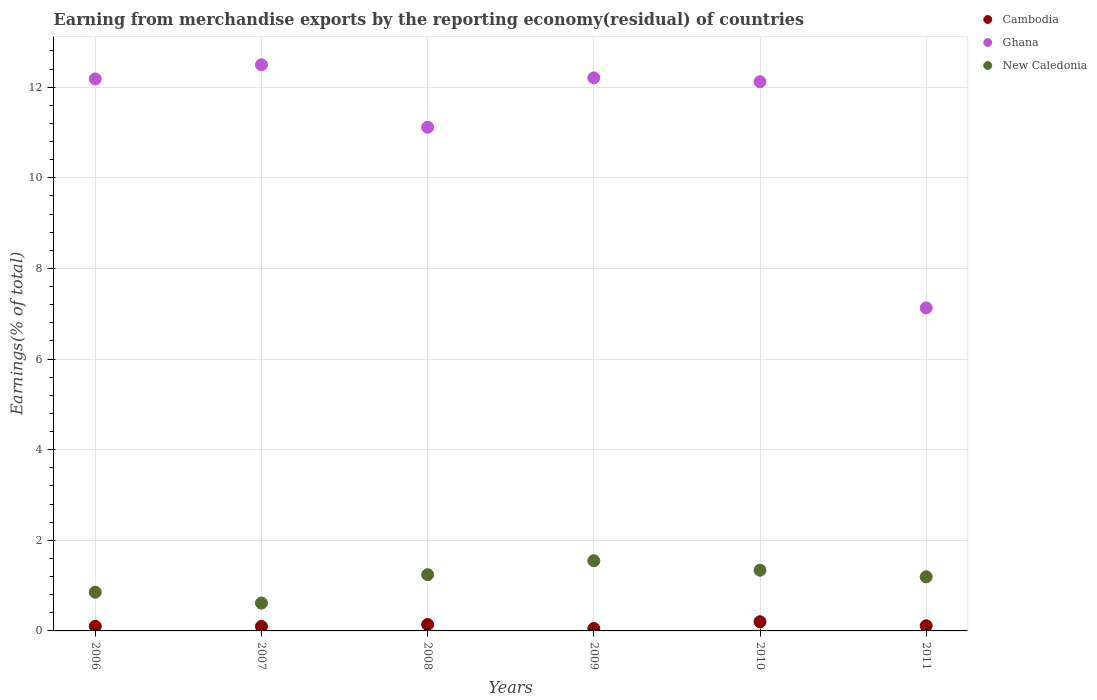How many different coloured dotlines are there?
Provide a succinct answer. 3. Is the number of dotlines equal to the number of legend labels?
Offer a terse response. Yes. What is the percentage of amount earned from merchandise exports in Cambodia in 2007?
Offer a very short reply. 0.1. Across all years, what is the maximum percentage of amount earned from merchandise exports in Ghana?
Provide a short and direct response. 12.5. Across all years, what is the minimum percentage of amount earned from merchandise exports in Cambodia?
Your answer should be compact. 0.05. What is the total percentage of amount earned from merchandise exports in New Caledonia in the graph?
Your answer should be very brief. 6.79. What is the difference between the percentage of amount earned from merchandise exports in New Caledonia in 2008 and that in 2011?
Your answer should be very brief. 0.05. What is the difference between the percentage of amount earned from merchandise exports in New Caledonia in 2011 and the percentage of amount earned from merchandise exports in Ghana in 2008?
Keep it short and to the point. -9.92. What is the average percentage of amount earned from merchandise exports in Ghana per year?
Give a very brief answer. 11.21. In the year 2009, what is the difference between the percentage of amount earned from merchandise exports in Cambodia and percentage of amount earned from merchandise exports in New Caledonia?
Offer a terse response. -1.5. In how many years, is the percentage of amount earned from merchandise exports in Ghana greater than 6.8 %?
Ensure brevity in your answer.  6. What is the ratio of the percentage of amount earned from merchandise exports in Cambodia in 2006 to that in 2008?
Offer a very short reply. 0.73. Is the difference between the percentage of amount earned from merchandise exports in Cambodia in 2006 and 2008 greater than the difference between the percentage of amount earned from merchandise exports in New Caledonia in 2006 and 2008?
Make the answer very short. Yes. What is the difference between the highest and the second highest percentage of amount earned from merchandise exports in New Caledonia?
Your answer should be compact. 0.21. What is the difference between the highest and the lowest percentage of amount earned from merchandise exports in New Caledonia?
Provide a succinct answer. 0.93. In how many years, is the percentage of amount earned from merchandise exports in Cambodia greater than the average percentage of amount earned from merchandise exports in Cambodia taken over all years?
Make the answer very short. 2. Is the percentage of amount earned from merchandise exports in New Caledonia strictly less than the percentage of amount earned from merchandise exports in Cambodia over the years?
Your answer should be very brief. No. How many dotlines are there?
Ensure brevity in your answer.  3. How many years are there in the graph?
Offer a terse response. 6. Does the graph contain any zero values?
Make the answer very short. No. Does the graph contain grids?
Your answer should be compact. Yes. How many legend labels are there?
Provide a succinct answer. 3. What is the title of the graph?
Your answer should be very brief. Earning from merchandise exports by the reporting economy(residual) of countries. What is the label or title of the X-axis?
Provide a short and direct response. Years. What is the label or title of the Y-axis?
Provide a succinct answer. Earnings(% of total). What is the Earnings(% of total) in Cambodia in 2006?
Offer a very short reply. 0.1. What is the Earnings(% of total) of Ghana in 2006?
Your answer should be compact. 12.18. What is the Earnings(% of total) of New Caledonia in 2006?
Offer a terse response. 0.85. What is the Earnings(% of total) of Cambodia in 2007?
Your answer should be compact. 0.1. What is the Earnings(% of total) in Ghana in 2007?
Give a very brief answer. 12.5. What is the Earnings(% of total) of New Caledonia in 2007?
Make the answer very short. 0.61. What is the Earnings(% of total) in Cambodia in 2008?
Your answer should be very brief. 0.14. What is the Earnings(% of total) in Ghana in 2008?
Your answer should be very brief. 11.12. What is the Earnings(% of total) in New Caledonia in 2008?
Your answer should be compact. 1.24. What is the Earnings(% of total) in Cambodia in 2009?
Give a very brief answer. 0.05. What is the Earnings(% of total) in Ghana in 2009?
Ensure brevity in your answer.  12.21. What is the Earnings(% of total) of New Caledonia in 2009?
Your response must be concise. 1.55. What is the Earnings(% of total) in Cambodia in 2010?
Give a very brief answer. 0.2. What is the Earnings(% of total) of Ghana in 2010?
Your answer should be very brief. 12.12. What is the Earnings(% of total) of New Caledonia in 2010?
Provide a succinct answer. 1.34. What is the Earnings(% of total) of Cambodia in 2011?
Give a very brief answer. 0.11. What is the Earnings(% of total) of Ghana in 2011?
Ensure brevity in your answer.  7.13. What is the Earnings(% of total) of New Caledonia in 2011?
Offer a very short reply. 1.19. Across all years, what is the maximum Earnings(% of total) of Cambodia?
Offer a terse response. 0.2. Across all years, what is the maximum Earnings(% of total) in Ghana?
Offer a terse response. 12.5. Across all years, what is the maximum Earnings(% of total) of New Caledonia?
Provide a short and direct response. 1.55. Across all years, what is the minimum Earnings(% of total) of Cambodia?
Make the answer very short. 0.05. Across all years, what is the minimum Earnings(% of total) in Ghana?
Provide a succinct answer. 7.13. Across all years, what is the minimum Earnings(% of total) of New Caledonia?
Provide a succinct answer. 0.61. What is the total Earnings(% of total) of Cambodia in the graph?
Your answer should be compact. 0.71. What is the total Earnings(% of total) of Ghana in the graph?
Your answer should be compact. 67.25. What is the total Earnings(% of total) of New Caledonia in the graph?
Your response must be concise. 6.79. What is the difference between the Earnings(% of total) in Cambodia in 2006 and that in 2007?
Give a very brief answer. 0. What is the difference between the Earnings(% of total) of Ghana in 2006 and that in 2007?
Offer a terse response. -0.31. What is the difference between the Earnings(% of total) of New Caledonia in 2006 and that in 2007?
Provide a short and direct response. 0.24. What is the difference between the Earnings(% of total) in Cambodia in 2006 and that in 2008?
Your answer should be very brief. -0.04. What is the difference between the Earnings(% of total) in Ghana in 2006 and that in 2008?
Your answer should be compact. 1.07. What is the difference between the Earnings(% of total) of New Caledonia in 2006 and that in 2008?
Your response must be concise. -0.39. What is the difference between the Earnings(% of total) of Cambodia in 2006 and that in 2009?
Your answer should be very brief. 0.05. What is the difference between the Earnings(% of total) in Ghana in 2006 and that in 2009?
Your answer should be compact. -0.02. What is the difference between the Earnings(% of total) of New Caledonia in 2006 and that in 2009?
Offer a very short reply. -0.69. What is the difference between the Earnings(% of total) of Cambodia in 2006 and that in 2010?
Offer a terse response. -0.1. What is the difference between the Earnings(% of total) of Ghana in 2006 and that in 2010?
Your response must be concise. 0.06. What is the difference between the Earnings(% of total) in New Caledonia in 2006 and that in 2010?
Your answer should be very brief. -0.49. What is the difference between the Earnings(% of total) of Cambodia in 2006 and that in 2011?
Keep it short and to the point. -0.01. What is the difference between the Earnings(% of total) in Ghana in 2006 and that in 2011?
Keep it short and to the point. 5.05. What is the difference between the Earnings(% of total) of New Caledonia in 2006 and that in 2011?
Give a very brief answer. -0.34. What is the difference between the Earnings(% of total) of Cambodia in 2007 and that in 2008?
Provide a short and direct response. -0.04. What is the difference between the Earnings(% of total) of Ghana in 2007 and that in 2008?
Ensure brevity in your answer.  1.38. What is the difference between the Earnings(% of total) in New Caledonia in 2007 and that in 2008?
Your answer should be compact. -0.63. What is the difference between the Earnings(% of total) of Cambodia in 2007 and that in 2009?
Your answer should be compact. 0.05. What is the difference between the Earnings(% of total) of Ghana in 2007 and that in 2009?
Give a very brief answer. 0.29. What is the difference between the Earnings(% of total) of New Caledonia in 2007 and that in 2009?
Give a very brief answer. -0.94. What is the difference between the Earnings(% of total) in Cambodia in 2007 and that in 2010?
Keep it short and to the point. -0.1. What is the difference between the Earnings(% of total) of Ghana in 2007 and that in 2010?
Make the answer very short. 0.38. What is the difference between the Earnings(% of total) in New Caledonia in 2007 and that in 2010?
Give a very brief answer. -0.73. What is the difference between the Earnings(% of total) of Cambodia in 2007 and that in 2011?
Provide a succinct answer. -0.01. What is the difference between the Earnings(% of total) in Ghana in 2007 and that in 2011?
Ensure brevity in your answer.  5.37. What is the difference between the Earnings(% of total) of New Caledonia in 2007 and that in 2011?
Give a very brief answer. -0.58. What is the difference between the Earnings(% of total) in Cambodia in 2008 and that in 2009?
Your response must be concise. 0.09. What is the difference between the Earnings(% of total) in Ghana in 2008 and that in 2009?
Give a very brief answer. -1.09. What is the difference between the Earnings(% of total) of New Caledonia in 2008 and that in 2009?
Offer a very short reply. -0.31. What is the difference between the Earnings(% of total) in Cambodia in 2008 and that in 2010?
Provide a short and direct response. -0.06. What is the difference between the Earnings(% of total) of Ghana in 2008 and that in 2010?
Provide a short and direct response. -1. What is the difference between the Earnings(% of total) of New Caledonia in 2008 and that in 2010?
Provide a succinct answer. -0.1. What is the difference between the Earnings(% of total) of Cambodia in 2008 and that in 2011?
Your response must be concise. 0.03. What is the difference between the Earnings(% of total) of Ghana in 2008 and that in 2011?
Your response must be concise. 3.99. What is the difference between the Earnings(% of total) in New Caledonia in 2008 and that in 2011?
Make the answer very short. 0.05. What is the difference between the Earnings(% of total) in Cambodia in 2009 and that in 2010?
Keep it short and to the point. -0.15. What is the difference between the Earnings(% of total) of Ghana in 2009 and that in 2010?
Your answer should be compact. 0.09. What is the difference between the Earnings(% of total) in New Caledonia in 2009 and that in 2010?
Your answer should be compact. 0.21. What is the difference between the Earnings(% of total) in Cambodia in 2009 and that in 2011?
Ensure brevity in your answer.  -0.06. What is the difference between the Earnings(% of total) of Ghana in 2009 and that in 2011?
Offer a very short reply. 5.08. What is the difference between the Earnings(% of total) of New Caledonia in 2009 and that in 2011?
Offer a very short reply. 0.35. What is the difference between the Earnings(% of total) in Cambodia in 2010 and that in 2011?
Your answer should be compact. 0.09. What is the difference between the Earnings(% of total) of Ghana in 2010 and that in 2011?
Offer a terse response. 4.99. What is the difference between the Earnings(% of total) in New Caledonia in 2010 and that in 2011?
Keep it short and to the point. 0.15. What is the difference between the Earnings(% of total) of Cambodia in 2006 and the Earnings(% of total) of Ghana in 2007?
Your response must be concise. -12.39. What is the difference between the Earnings(% of total) of Cambodia in 2006 and the Earnings(% of total) of New Caledonia in 2007?
Give a very brief answer. -0.51. What is the difference between the Earnings(% of total) in Ghana in 2006 and the Earnings(% of total) in New Caledonia in 2007?
Your answer should be compact. 11.57. What is the difference between the Earnings(% of total) of Cambodia in 2006 and the Earnings(% of total) of Ghana in 2008?
Make the answer very short. -11.01. What is the difference between the Earnings(% of total) in Cambodia in 2006 and the Earnings(% of total) in New Caledonia in 2008?
Provide a succinct answer. -1.14. What is the difference between the Earnings(% of total) in Ghana in 2006 and the Earnings(% of total) in New Caledonia in 2008?
Give a very brief answer. 10.94. What is the difference between the Earnings(% of total) of Cambodia in 2006 and the Earnings(% of total) of Ghana in 2009?
Ensure brevity in your answer.  -12.1. What is the difference between the Earnings(% of total) in Cambodia in 2006 and the Earnings(% of total) in New Caledonia in 2009?
Offer a very short reply. -1.45. What is the difference between the Earnings(% of total) in Ghana in 2006 and the Earnings(% of total) in New Caledonia in 2009?
Your answer should be compact. 10.63. What is the difference between the Earnings(% of total) of Cambodia in 2006 and the Earnings(% of total) of Ghana in 2010?
Provide a short and direct response. -12.02. What is the difference between the Earnings(% of total) of Cambodia in 2006 and the Earnings(% of total) of New Caledonia in 2010?
Give a very brief answer. -1.24. What is the difference between the Earnings(% of total) in Ghana in 2006 and the Earnings(% of total) in New Caledonia in 2010?
Offer a terse response. 10.84. What is the difference between the Earnings(% of total) in Cambodia in 2006 and the Earnings(% of total) in Ghana in 2011?
Provide a succinct answer. -7.03. What is the difference between the Earnings(% of total) in Cambodia in 2006 and the Earnings(% of total) in New Caledonia in 2011?
Provide a succinct answer. -1.09. What is the difference between the Earnings(% of total) in Ghana in 2006 and the Earnings(% of total) in New Caledonia in 2011?
Your answer should be very brief. 10.99. What is the difference between the Earnings(% of total) of Cambodia in 2007 and the Earnings(% of total) of Ghana in 2008?
Provide a succinct answer. -11.02. What is the difference between the Earnings(% of total) in Cambodia in 2007 and the Earnings(% of total) in New Caledonia in 2008?
Make the answer very short. -1.14. What is the difference between the Earnings(% of total) in Ghana in 2007 and the Earnings(% of total) in New Caledonia in 2008?
Give a very brief answer. 11.25. What is the difference between the Earnings(% of total) of Cambodia in 2007 and the Earnings(% of total) of Ghana in 2009?
Your answer should be compact. -12.11. What is the difference between the Earnings(% of total) of Cambodia in 2007 and the Earnings(% of total) of New Caledonia in 2009?
Offer a terse response. -1.45. What is the difference between the Earnings(% of total) of Ghana in 2007 and the Earnings(% of total) of New Caledonia in 2009?
Your response must be concise. 10.95. What is the difference between the Earnings(% of total) of Cambodia in 2007 and the Earnings(% of total) of Ghana in 2010?
Provide a succinct answer. -12.02. What is the difference between the Earnings(% of total) in Cambodia in 2007 and the Earnings(% of total) in New Caledonia in 2010?
Offer a terse response. -1.24. What is the difference between the Earnings(% of total) in Ghana in 2007 and the Earnings(% of total) in New Caledonia in 2010?
Give a very brief answer. 11.16. What is the difference between the Earnings(% of total) in Cambodia in 2007 and the Earnings(% of total) in Ghana in 2011?
Keep it short and to the point. -7.03. What is the difference between the Earnings(% of total) in Cambodia in 2007 and the Earnings(% of total) in New Caledonia in 2011?
Your answer should be compact. -1.1. What is the difference between the Earnings(% of total) in Ghana in 2007 and the Earnings(% of total) in New Caledonia in 2011?
Your answer should be compact. 11.3. What is the difference between the Earnings(% of total) of Cambodia in 2008 and the Earnings(% of total) of Ghana in 2009?
Provide a short and direct response. -12.07. What is the difference between the Earnings(% of total) of Cambodia in 2008 and the Earnings(% of total) of New Caledonia in 2009?
Offer a terse response. -1.41. What is the difference between the Earnings(% of total) in Ghana in 2008 and the Earnings(% of total) in New Caledonia in 2009?
Your response must be concise. 9.57. What is the difference between the Earnings(% of total) in Cambodia in 2008 and the Earnings(% of total) in Ghana in 2010?
Give a very brief answer. -11.98. What is the difference between the Earnings(% of total) of Cambodia in 2008 and the Earnings(% of total) of New Caledonia in 2010?
Keep it short and to the point. -1.2. What is the difference between the Earnings(% of total) in Ghana in 2008 and the Earnings(% of total) in New Caledonia in 2010?
Give a very brief answer. 9.78. What is the difference between the Earnings(% of total) in Cambodia in 2008 and the Earnings(% of total) in Ghana in 2011?
Provide a short and direct response. -6.99. What is the difference between the Earnings(% of total) of Cambodia in 2008 and the Earnings(% of total) of New Caledonia in 2011?
Ensure brevity in your answer.  -1.05. What is the difference between the Earnings(% of total) in Ghana in 2008 and the Earnings(% of total) in New Caledonia in 2011?
Your answer should be compact. 9.92. What is the difference between the Earnings(% of total) in Cambodia in 2009 and the Earnings(% of total) in Ghana in 2010?
Make the answer very short. -12.07. What is the difference between the Earnings(% of total) in Cambodia in 2009 and the Earnings(% of total) in New Caledonia in 2010?
Keep it short and to the point. -1.29. What is the difference between the Earnings(% of total) in Ghana in 2009 and the Earnings(% of total) in New Caledonia in 2010?
Offer a terse response. 10.87. What is the difference between the Earnings(% of total) of Cambodia in 2009 and the Earnings(% of total) of Ghana in 2011?
Provide a succinct answer. -7.08. What is the difference between the Earnings(% of total) of Cambodia in 2009 and the Earnings(% of total) of New Caledonia in 2011?
Provide a succinct answer. -1.14. What is the difference between the Earnings(% of total) in Ghana in 2009 and the Earnings(% of total) in New Caledonia in 2011?
Your answer should be compact. 11.01. What is the difference between the Earnings(% of total) in Cambodia in 2010 and the Earnings(% of total) in Ghana in 2011?
Offer a very short reply. -6.93. What is the difference between the Earnings(% of total) in Cambodia in 2010 and the Earnings(% of total) in New Caledonia in 2011?
Make the answer very short. -0.99. What is the difference between the Earnings(% of total) in Ghana in 2010 and the Earnings(% of total) in New Caledonia in 2011?
Your response must be concise. 10.93. What is the average Earnings(% of total) of Cambodia per year?
Your answer should be very brief. 0.12. What is the average Earnings(% of total) in Ghana per year?
Your answer should be very brief. 11.21. What is the average Earnings(% of total) of New Caledonia per year?
Provide a succinct answer. 1.13. In the year 2006, what is the difference between the Earnings(% of total) of Cambodia and Earnings(% of total) of Ghana?
Ensure brevity in your answer.  -12.08. In the year 2006, what is the difference between the Earnings(% of total) of Cambodia and Earnings(% of total) of New Caledonia?
Keep it short and to the point. -0.75. In the year 2006, what is the difference between the Earnings(% of total) of Ghana and Earnings(% of total) of New Caledonia?
Your response must be concise. 11.33. In the year 2007, what is the difference between the Earnings(% of total) of Cambodia and Earnings(% of total) of Ghana?
Provide a succinct answer. -12.4. In the year 2007, what is the difference between the Earnings(% of total) in Cambodia and Earnings(% of total) in New Caledonia?
Keep it short and to the point. -0.52. In the year 2007, what is the difference between the Earnings(% of total) in Ghana and Earnings(% of total) in New Caledonia?
Make the answer very short. 11.88. In the year 2008, what is the difference between the Earnings(% of total) in Cambodia and Earnings(% of total) in Ghana?
Your response must be concise. -10.98. In the year 2008, what is the difference between the Earnings(% of total) of Cambodia and Earnings(% of total) of New Caledonia?
Your answer should be compact. -1.1. In the year 2008, what is the difference between the Earnings(% of total) of Ghana and Earnings(% of total) of New Caledonia?
Give a very brief answer. 9.88. In the year 2009, what is the difference between the Earnings(% of total) in Cambodia and Earnings(% of total) in Ghana?
Provide a succinct answer. -12.15. In the year 2009, what is the difference between the Earnings(% of total) of Cambodia and Earnings(% of total) of New Caledonia?
Offer a terse response. -1.5. In the year 2009, what is the difference between the Earnings(% of total) of Ghana and Earnings(% of total) of New Caledonia?
Make the answer very short. 10.66. In the year 2010, what is the difference between the Earnings(% of total) of Cambodia and Earnings(% of total) of Ghana?
Offer a terse response. -11.92. In the year 2010, what is the difference between the Earnings(% of total) of Cambodia and Earnings(% of total) of New Caledonia?
Give a very brief answer. -1.14. In the year 2010, what is the difference between the Earnings(% of total) of Ghana and Earnings(% of total) of New Caledonia?
Offer a terse response. 10.78. In the year 2011, what is the difference between the Earnings(% of total) of Cambodia and Earnings(% of total) of Ghana?
Provide a short and direct response. -7.02. In the year 2011, what is the difference between the Earnings(% of total) in Cambodia and Earnings(% of total) in New Caledonia?
Keep it short and to the point. -1.08. In the year 2011, what is the difference between the Earnings(% of total) of Ghana and Earnings(% of total) of New Caledonia?
Offer a terse response. 5.93. What is the ratio of the Earnings(% of total) in Cambodia in 2006 to that in 2007?
Ensure brevity in your answer.  1.03. What is the ratio of the Earnings(% of total) of Ghana in 2006 to that in 2007?
Make the answer very short. 0.97. What is the ratio of the Earnings(% of total) in New Caledonia in 2006 to that in 2007?
Offer a terse response. 1.39. What is the ratio of the Earnings(% of total) of Cambodia in 2006 to that in 2008?
Keep it short and to the point. 0.73. What is the ratio of the Earnings(% of total) in Ghana in 2006 to that in 2008?
Ensure brevity in your answer.  1.1. What is the ratio of the Earnings(% of total) in New Caledonia in 2006 to that in 2008?
Give a very brief answer. 0.69. What is the ratio of the Earnings(% of total) of Cambodia in 2006 to that in 2009?
Give a very brief answer. 1.93. What is the ratio of the Earnings(% of total) of New Caledonia in 2006 to that in 2009?
Offer a terse response. 0.55. What is the ratio of the Earnings(% of total) of Cambodia in 2006 to that in 2010?
Keep it short and to the point. 0.51. What is the ratio of the Earnings(% of total) of Ghana in 2006 to that in 2010?
Offer a very short reply. 1.01. What is the ratio of the Earnings(% of total) of New Caledonia in 2006 to that in 2010?
Your answer should be compact. 0.64. What is the ratio of the Earnings(% of total) of Cambodia in 2006 to that in 2011?
Your answer should be very brief. 0.91. What is the ratio of the Earnings(% of total) of Ghana in 2006 to that in 2011?
Make the answer very short. 1.71. What is the ratio of the Earnings(% of total) in New Caledonia in 2006 to that in 2011?
Keep it short and to the point. 0.72. What is the ratio of the Earnings(% of total) of Cambodia in 2007 to that in 2008?
Offer a terse response. 0.7. What is the ratio of the Earnings(% of total) in Ghana in 2007 to that in 2008?
Keep it short and to the point. 1.12. What is the ratio of the Earnings(% of total) in New Caledonia in 2007 to that in 2008?
Your response must be concise. 0.5. What is the ratio of the Earnings(% of total) in Cambodia in 2007 to that in 2009?
Your answer should be very brief. 1.86. What is the ratio of the Earnings(% of total) of Ghana in 2007 to that in 2009?
Offer a very short reply. 1.02. What is the ratio of the Earnings(% of total) of New Caledonia in 2007 to that in 2009?
Your answer should be compact. 0.4. What is the ratio of the Earnings(% of total) of Cambodia in 2007 to that in 2010?
Offer a terse response. 0.49. What is the ratio of the Earnings(% of total) of Ghana in 2007 to that in 2010?
Your answer should be compact. 1.03. What is the ratio of the Earnings(% of total) in New Caledonia in 2007 to that in 2010?
Make the answer very short. 0.46. What is the ratio of the Earnings(% of total) of Cambodia in 2007 to that in 2011?
Ensure brevity in your answer.  0.88. What is the ratio of the Earnings(% of total) of Ghana in 2007 to that in 2011?
Provide a succinct answer. 1.75. What is the ratio of the Earnings(% of total) of New Caledonia in 2007 to that in 2011?
Make the answer very short. 0.51. What is the ratio of the Earnings(% of total) in Cambodia in 2008 to that in 2009?
Provide a short and direct response. 2.64. What is the ratio of the Earnings(% of total) in Ghana in 2008 to that in 2009?
Make the answer very short. 0.91. What is the ratio of the Earnings(% of total) in New Caledonia in 2008 to that in 2009?
Your answer should be very brief. 0.8. What is the ratio of the Earnings(% of total) in Cambodia in 2008 to that in 2010?
Provide a short and direct response. 0.7. What is the ratio of the Earnings(% of total) in Ghana in 2008 to that in 2010?
Ensure brevity in your answer.  0.92. What is the ratio of the Earnings(% of total) of New Caledonia in 2008 to that in 2010?
Keep it short and to the point. 0.93. What is the ratio of the Earnings(% of total) in Cambodia in 2008 to that in 2011?
Your response must be concise. 1.25. What is the ratio of the Earnings(% of total) in Ghana in 2008 to that in 2011?
Make the answer very short. 1.56. What is the ratio of the Earnings(% of total) in New Caledonia in 2008 to that in 2011?
Offer a very short reply. 1.04. What is the ratio of the Earnings(% of total) of Cambodia in 2009 to that in 2010?
Ensure brevity in your answer.  0.26. What is the ratio of the Earnings(% of total) of Ghana in 2009 to that in 2010?
Provide a succinct answer. 1.01. What is the ratio of the Earnings(% of total) of New Caledonia in 2009 to that in 2010?
Your answer should be compact. 1.16. What is the ratio of the Earnings(% of total) in Cambodia in 2009 to that in 2011?
Offer a terse response. 0.47. What is the ratio of the Earnings(% of total) of Ghana in 2009 to that in 2011?
Your response must be concise. 1.71. What is the ratio of the Earnings(% of total) of New Caledonia in 2009 to that in 2011?
Your answer should be compact. 1.3. What is the ratio of the Earnings(% of total) in Cambodia in 2010 to that in 2011?
Offer a very short reply. 1.79. What is the ratio of the Earnings(% of total) of Ghana in 2010 to that in 2011?
Your answer should be very brief. 1.7. What is the ratio of the Earnings(% of total) of New Caledonia in 2010 to that in 2011?
Offer a very short reply. 1.12. What is the difference between the highest and the second highest Earnings(% of total) in Cambodia?
Ensure brevity in your answer.  0.06. What is the difference between the highest and the second highest Earnings(% of total) in Ghana?
Give a very brief answer. 0.29. What is the difference between the highest and the second highest Earnings(% of total) of New Caledonia?
Your answer should be very brief. 0.21. What is the difference between the highest and the lowest Earnings(% of total) of Cambodia?
Your answer should be compact. 0.15. What is the difference between the highest and the lowest Earnings(% of total) in Ghana?
Your answer should be compact. 5.37. What is the difference between the highest and the lowest Earnings(% of total) in New Caledonia?
Your response must be concise. 0.94. 